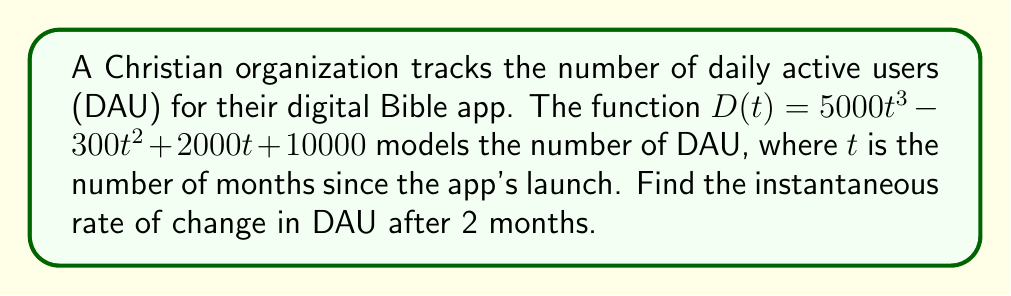Can you solve this math problem? To find the instantaneous rate of change, we need to calculate the derivative of the function $D(t)$ and evaluate it at $t=2$.

Step 1: Find the derivative of $D(t)$
$$D'(t) = \frac{d}{dt}(5000t^3 - 300t^2 + 2000t + 10000)$$
$$D'(t) = 15000t^2 - 600t + 2000$$

Step 2: Evaluate $D'(t)$ at $t=2$
$$D'(2) = 15000(2)^2 - 600(2) + 2000$$
$$D'(2) = 15000(4) - 1200 + 2000$$
$$D'(2) = 60000 - 1200 + 2000$$
$$D'(2) = 60800$$

The instantaneous rate of change after 2 months is 60,800 users per month.
Answer: 60,800 users/month 